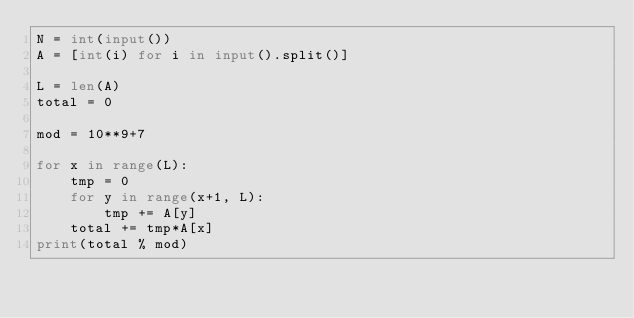<code> <loc_0><loc_0><loc_500><loc_500><_Python_>N = int(input())
A = [int(i) for i in input().split()]

L = len(A)
total = 0

mod = 10**9+7

for x in range(L):
    tmp = 0
    for y in range(x+1, L):
        tmp += A[y]
    total += tmp*A[x]
print(total % mod)
</code> 